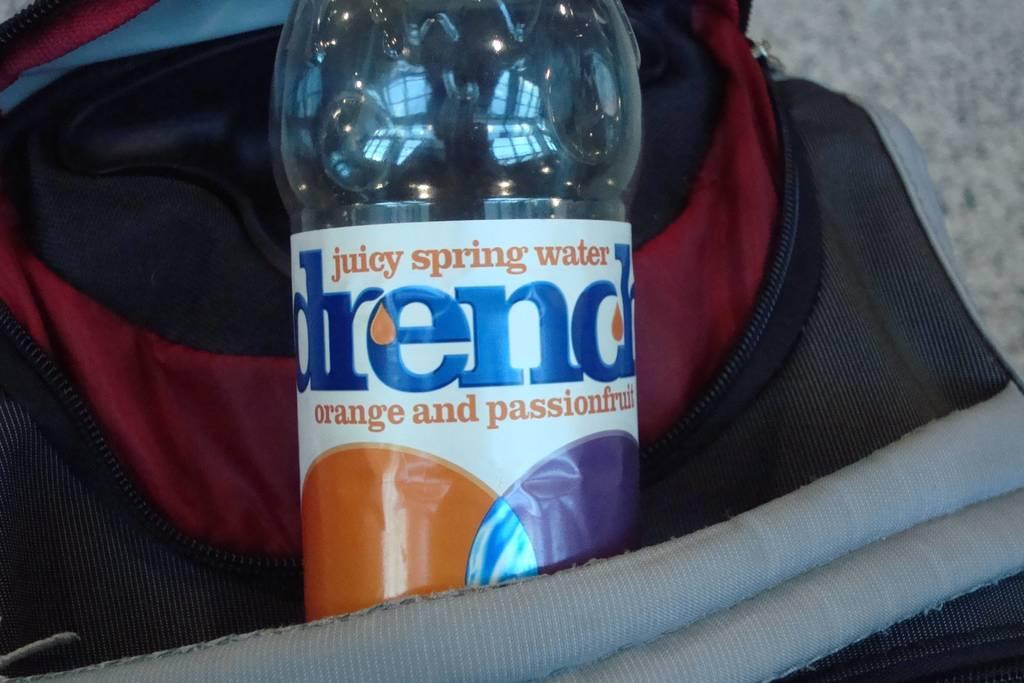What object can be seen in the image? There is a bottle in the image. Where is the bottle located? The bottle is on a bag. What can be seen in the background of the image? There is a floor visible in the background of the image. What type of coal can be seen in the image? There is no coal present in the image. Is there a ship visible in the image? There is no ship present in the image. 